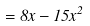<formula> <loc_0><loc_0><loc_500><loc_500>= 8 x - 1 5 x ^ { 2 }</formula> 